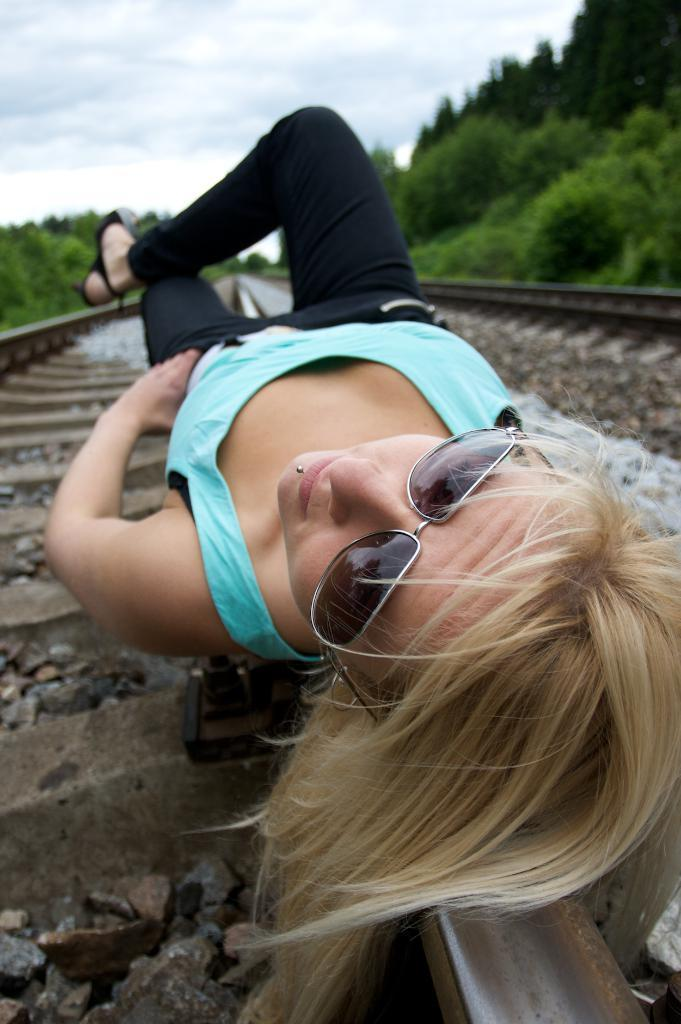What is the main subject of the image? There is a lady laying on the railway track in the center of the image. What can be seen on both sides of the image? There are trees on both sides of the image. What type of dust can be seen on the lady's clothes in the image? There is no dust visible on the lady's clothes in the image. What is the temperature like in the image? The provided facts do not mention the temperature or weather conditions, so it cannot be determined from the image. 